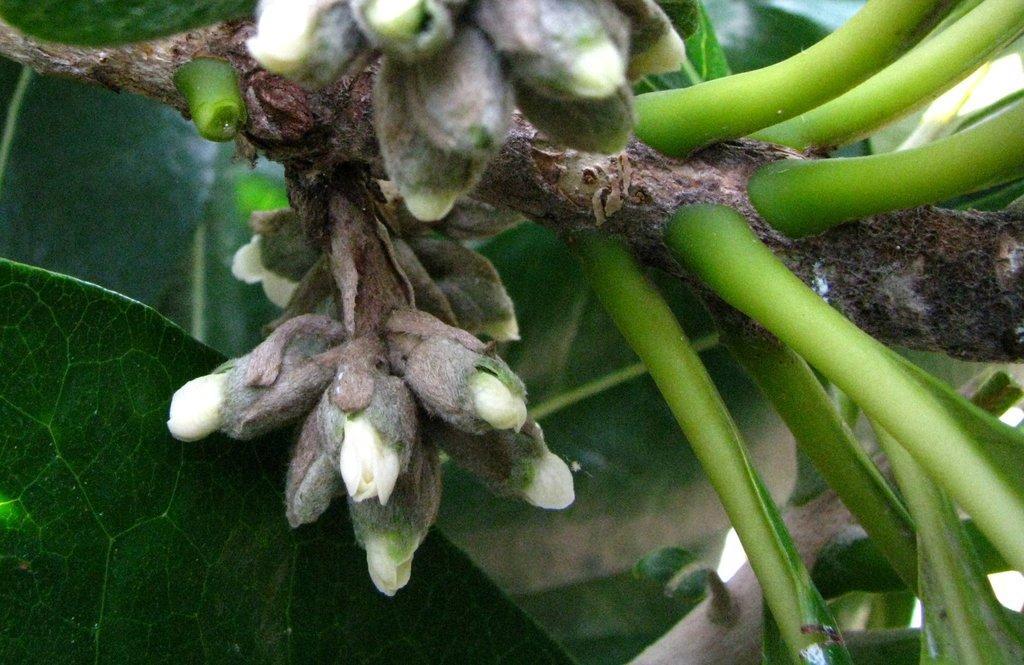Could you give a brief overview of what you see in this image? In this picture we can see flowers and in the background we can see leaves. 